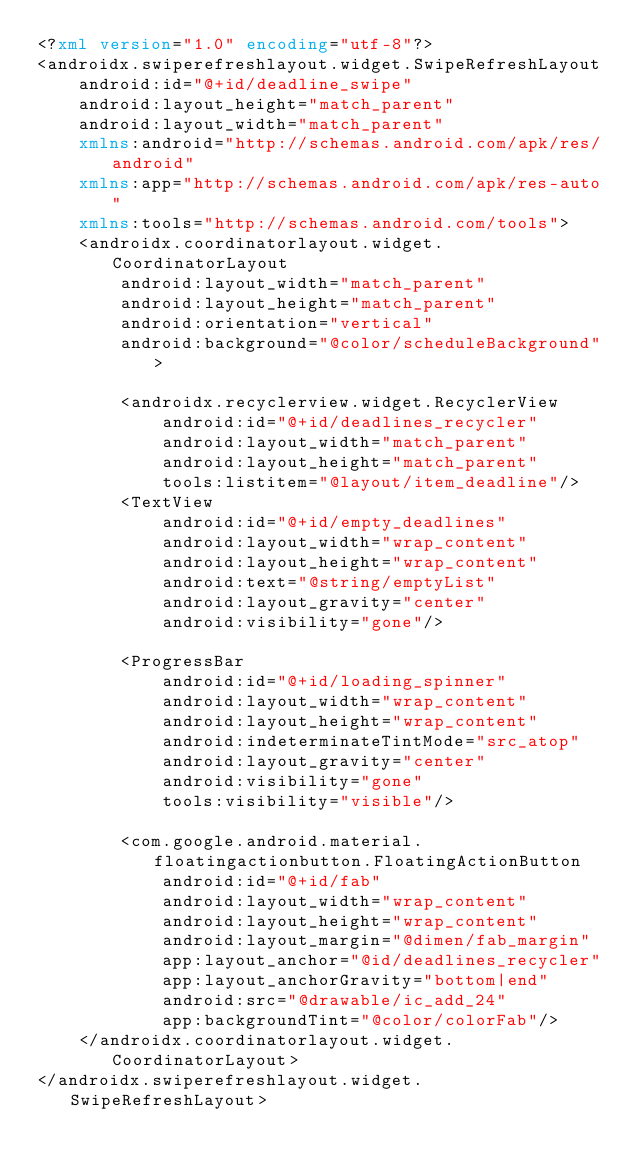Convert code to text. <code><loc_0><loc_0><loc_500><loc_500><_XML_><?xml version="1.0" encoding="utf-8"?>
<androidx.swiperefreshlayout.widget.SwipeRefreshLayout
    android:id="@+id/deadline_swipe"
    android:layout_height="match_parent"
    android:layout_width="match_parent"
    xmlns:android="http://schemas.android.com/apk/res/android"
    xmlns:app="http://schemas.android.com/apk/res-auto"
    xmlns:tools="http://schemas.android.com/tools">
    <androidx.coordinatorlayout.widget.CoordinatorLayout
        android:layout_width="match_parent"
        android:layout_height="match_parent"
        android:orientation="vertical"
        android:background="@color/scheduleBackground">

        <androidx.recyclerview.widget.RecyclerView
            android:id="@+id/deadlines_recycler"
            android:layout_width="match_parent"
            android:layout_height="match_parent"
            tools:listitem="@layout/item_deadline"/>
        <TextView
            android:id="@+id/empty_deadlines"
            android:layout_width="wrap_content"
            android:layout_height="wrap_content"
            android:text="@string/emptyList"
            android:layout_gravity="center"
            android:visibility="gone"/>

        <ProgressBar
            android:id="@+id/loading_spinner"
            android:layout_width="wrap_content"
            android:layout_height="wrap_content"
            android:indeterminateTintMode="src_atop"
            android:layout_gravity="center"
            android:visibility="gone"
            tools:visibility="visible"/>

        <com.google.android.material.floatingactionbutton.FloatingActionButton
            android:id="@+id/fab"
            android:layout_width="wrap_content"
            android:layout_height="wrap_content"
            android:layout_margin="@dimen/fab_margin"
            app:layout_anchor="@id/deadlines_recycler"
            app:layout_anchorGravity="bottom|end"
            android:src="@drawable/ic_add_24"
            app:backgroundTint="@color/colorFab"/>
    </androidx.coordinatorlayout.widget.CoordinatorLayout>
</androidx.swiperefreshlayout.widget.SwipeRefreshLayout>
</code> 